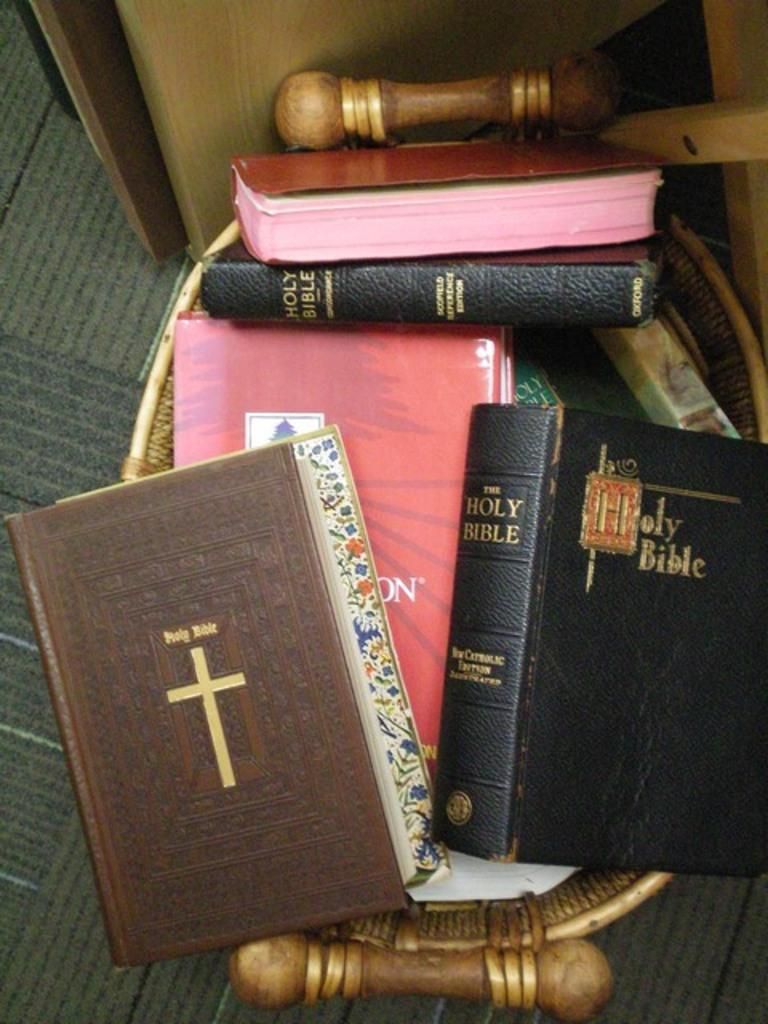<image>
Offer a succinct explanation of the picture presented. A collection of books which are the Holy Bible. 